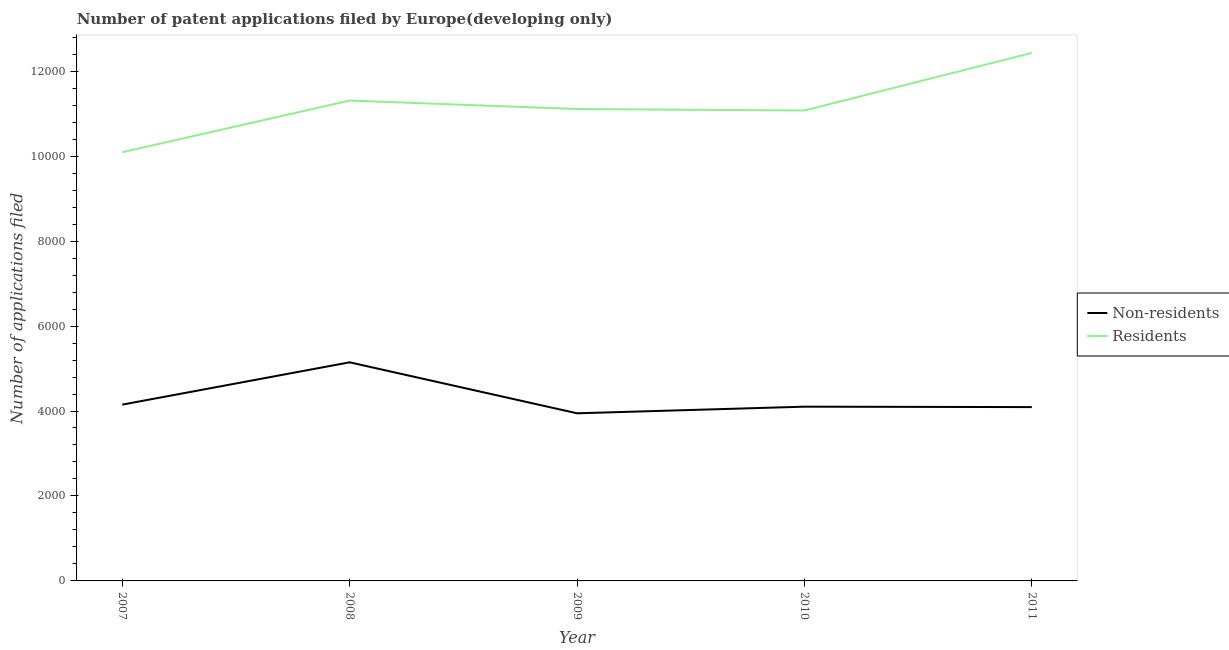Does the line corresponding to number of patent applications by non residents intersect with the line corresponding to number of patent applications by residents?
Keep it short and to the point. No. What is the number of patent applications by non residents in 2009?
Keep it short and to the point. 3946. Across all years, what is the maximum number of patent applications by residents?
Your answer should be very brief. 1.24e+04. Across all years, what is the minimum number of patent applications by residents?
Make the answer very short. 1.01e+04. In which year was the number of patent applications by residents minimum?
Offer a very short reply. 2007. What is the total number of patent applications by residents in the graph?
Your response must be concise. 5.60e+04. What is the difference between the number of patent applications by non residents in 2008 and that in 2011?
Offer a very short reply. 1054. What is the difference between the number of patent applications by residents in 2007 and the number of patent applications by non residents in 2010?
Offer a terse response. 5990. What is the average number of patent applications by non residents per year?
Your answer should be very brief. 4287.2. In the year 2009, what is the difference between the number of patent applications by non residents and number of patent applications by residents?
Your answer should be compact. -7163. What is the ratio of the number of patent applications by residents in 2008 to that in 2010?
Your answer should be very brief. 1.02. What is the difference between the highest and the second highest number of patent applications by residents?
Your response must be concise. 1122. What is the difference between the highest and the lowest number of patent applications by non residents?
Offer a terse response. 1200. In how many years, is the number of patent applications by non residents greater than the average number of patent applications by non residents taken over all years?
Ensure brevity in your answer.  1. Does the number of patent applications by residents monotonically increase over the years?
Make the answer very short. No. Is the number of patent applications by non residents strictly greater than the number of patent applications by residents over the years?
Give a very brief answer. No. Is the number of patent applications by non residents strictly less than the number of patent applications by residents over the years?
Make the answer very short. Yes. How many lines are there?
Your response must be concise. 2. Does the graph contain grids?
Provide a short and direct response. No. Where does the legend appear in the graph?
Keep it short and to the point. Center right. What is the title of the graph?
Your answer should be compact. Number of patent applications filed by Europe(developing only). Does "Quality of trade" appear as one of the legend labels in the graph?
Your response must be concise. No. What is the label or title of the X-axis?
Provide a succinct answer. Year. What is the label or title of the Y-axis?
Give a very brief answer. Number of applications filed. What is the Number of applications filed of Non-residents in 2007?
Your response must be concise. 4150. What is the Number of applications filed in Residents in 2007?
Your answer should be compact. 1.01e+04. What is the Number of applications filed in Non-residents in 2008?
Your answer should be compact. 5146. What is the Number of applications filed in Residents in 2008?
Make the answer very short. 1.13e+04. What is the Number of applications filed in Non-residents in 2009?
Your answer should be very brief. 3946. What is the Number of applications filed of Residents in 2009?
Provide a short and direct response. 1.11e+04. What is the Number of applications filed in Non-residents in 2010?
Make the answer very short. 4102. What is the Number of applications filed of Residents in 2010?
Offer a very short reply. 1.11e+04. What is the Number of applications filed in Non-residents in 2011?
Ensure brevity in your answer.  4092. What is the Number of applications filed in Residents in 2011?
Your answer should be compact. 1.24e+04. Across all years, what is the maximum Number of applications filed in Non-residents?
Offer a terse response. 5146. Across all years, what is the maximum Number of applications filed in Residents?
Keep it short and to the point. 1.24e+04. Across all years, what is the minimum Number of applications filed in Non-residents?
Your answer should be compact. 3946. Across all years, what is the minimum Number of applications filed in Residents?
Offer a very short reply. 1.01e+04. What is the total Number of applications filed in Non-residents in the graph?
Provide a short and direct response. 2.14e+04. What is the total Number of applications filed of Residents in the graph?
Your answer should be compact. 5.60e+04. What is the difference between the Number of applications filed in Non-residents in 2007 and that in 2008?
Offer a terse response. -996. What is the difference between the Number of applications filed in Residents in 2007 and that in 2008?
Provide a short and direct response. -1216. What is the difference between the Number of applications filed of Non-residents in 2007 and that in 2009?
Your answer should be compact. 204. What is the difference between the Number of applications filed of Residents in 2007 and that in 2009?
Offer a very short reply. -1017. What is the difference between the Number of applications filed of Non-residents in 2007 and that in 2010?
Offer a very short reply. 48. What is the difference between the Number of applications filed of Residents in 2007 and that in 2010?
Make the answer very short. -982. What is the difference between the Number of applications filed in Non-residents in 2007 and that in 2011?
Your answer should be very brief. 58. What is the difference between the Number of applications filed of Residents in 2007 and that in 2011?
Your response must be concise. -2338. What is the difference between the Number of applications filed of Non-residents in 2008 and that in 2009?
Offer a very short reply. 1200. What is the difference between the Number of applications filed in Residents in 2008 and that in 2009?
Give a very brief answer. 199. What is the difference between the Number of applications filed of Non-residents in 2008 and that in 2010?
Keep it short and to the point. 1044. What is the difference between the Number of applications filed in Residents in 2008 and that in 2010?
Keep it short and to the point. 234. What is the difference between the Number of applications filed of Non-residents in 2008 and that in 2011?
Your answer should be very brief. 1054. What is the difference between the Number of applications filed of Residents in 2008 and that in 2011?
Keep it short and to the point. -1122. What is the difference between the Number of applications filed in Non-residents in 2009 and that in 2010?
Your answer should be very brief. -156. What is the difference between the Number of applications filed of Residents in 2009 and that in 2010?
Provide a short and direct response. 35. What is the difference between the Number of applications filed of Non-residents in 2009 and that in 2011?
Keep it short and to the point. -146. What is the difference between the Number of applications filed of Residents in 2009 and that in 2011?
Keep it short and to the point. -1321. What is the difference between the Number of applications filed in Non-residents in 2010 and that in 2011?
Give a very brief answer. 10. What is the difference between the Number of applications filed of Residents in 2010 and that in 2011?
Your answer should be compact. -1356. What is the difference between the Number of applications filed of Non-residents in 2007 and the Number of applications filed of Residents in 2008?
Your answer should be very brief. -7158. What is the difference between the Number of applications filed in Non-residents in 2007 and the Number of applications filed in Residents in 2009?
Your answer should be compact. -6959. What is the difference between the Number of applications filed in Non-residents in 2007 and the Number of applications filed in Residents in 2010?
Make the answer very short. -6924. What is the difference between the Number of applications filed of Non-residents in 2007 and the Number of applications filed of Residents in 2011?
Your answer should be very brief. -8280. What is the difference between the Number of applications filed in Non-residents in 2008 and the Number of applications filed in Residents in 2009?
Offer a terse response. -5963. What is the difference between the Number of applications filed in Non-residents in 2008 and the Number of applications filed in Residents in 2010?
Your answer should be very brief. -5928. What is the difference between the Number of applications filed of Non-residents in 2008 and the Number of applications filed of Residents in 2011?
Offer a terse response. -7284. What is the difference between the Number of applications filed of Non-residents in 2009 and the Number of applications filed of Residents in 2010?
Provide a succinct answer. -7128. What is the difference between the Number of applications filed in Non-residents in 2009 and the Number of applications filed in Residents in 2011?
Your answer should be very brief. -8484. What is the difference between the Number of applications filed in Non-residents in 2010 and the Number of applications filed in Residents in 2011?
Provide a short and direct response. -8328. What is the average Number of applications filed of Non-residents per year?
Keep it short and to the point. 4287.2. What is the average Number of applications filed in Residents per year?
Offer a very short reply. 1.12e+04. In the year 2007, what is the difference between the Number of applications filed in Non-residents and Number of applications filed in Residents?
Your response must be concise. -5942. In the year 2008, what is the difference between the Number of applications filed in Non-residents and Number of applications filed in Residents?
Your answer should be very brief. -6162. In the year 2009, what is the difference between the Number of applications filed of Non-residents and Number of applications filed of Residents?
Offer a very short reply. -7163. In the year 2010, what is the difference between the Number of applications filed of Non-residents and Number of applications filed of Residents?
Ensure brevity in your answer.  -6972. In the year 2011, what is the difference between the Number of applications filed in Non-residents and Number of applications filed in Residents?
Provide a short and direct response. -8338. What is the ratio of the Number of applications filed in Non-residents in 2007 to that in 2008?
Provide a succinct answer. 0.81. What is the ratio of the Number of applications filed of Residents in 2007 to that in 2008?
Provide a short and direct response. 0.89. What is the ratio of the Number of applications filed of Non-residents in 2007 to that in 2009?
Offer a very short reply. 1.05. What is the ratio of the Number of applications filed of Residents in 2007 to that in 2009?
Provide a succinct answer. 0.91. What is the ratio of the Number of applications filed of Non-residents in 2007 to that in 2010?
Provide a succinct answer. 1.01. What is the ratio of the Number of applications filed of Residents in 2007 to that in 2010?
Give a very brief answer. 0.91. What is the ratio of the Number of applications filed of Non-residents in 2007 to that in 2011?
Your answer should be compact. 1.01. What is the ratio of the Number of applications filed of Residents in 2007 to that in 2011?
Your answer should be very brief. 0.81. What is the ratio of the Number of applications filed in Non-residents in 2008 to that in 2009?
Keep it short and to the point. 1.3. What is the ratio of the Number of applications filed of Residents in 2008 to that in 2009?
Make the answer very short. 1.02. What is the ratio of the Number of applications filed in Non-residents in 2008 to that in 2010?
Provide a succinct answer. 1.25. What is the ratio of the Number of applications filed of Residents in 2008 to that in 2010?
Offer a very short reply. 1.02. What is the ratio of the Number of applications filed of Non-residents in 2008 to that in 2011?
Offer a very short reply. 1.26. What is the ratio of the Number of applications filed of Residents in 2008 to that in 2011?
Offer a terse response. 0.91. What is the ratio of the Number of applications filed of Residents in 2009 to that in 2010?
Offer a very short reply. 1. What is the ratio of the Number of applications filed in Non-residents in 2009 to that in 2011?
Keep it short and to the point. 0.96. What is the ratio of the Number of applications filed of Residents in 2009 to that in 2011?
Give a very brief answer. 0.89. What is the ratio of the Number of applications filed in Residents in 2010 to that in 2011?
Your answer should be very brief. 0.89. What is the difference between the highest and the second highest Number of applications filed of Non-residents?
Keep it short and to the point. 996. What is the difference between the highest and the second highest Number of applications filed of Residents?
Your answer should be compact. 1122. What is the difference between the highest and the lowest Number of applications filed in Non-residents?
Your response must be concise. 1200. What is the difference between the highest and the lowest Number of applications filed of Residents?
Give a very brief answer. 2338. 